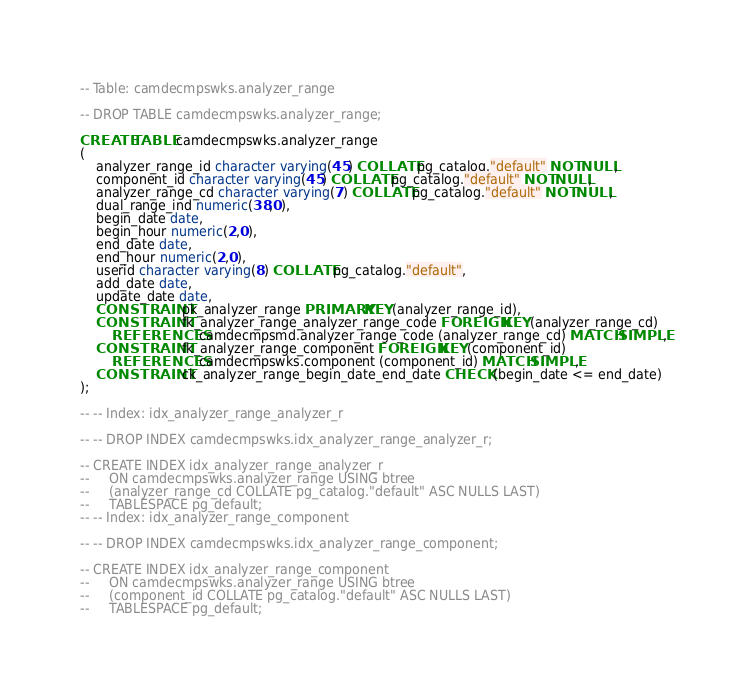Convert code to text. <code><loc_0><loc_0><loc_500><loc_500><_SQL_>-- Table: camdecmpswks.analyzer_range

-- DROP TABLE camdecmpswks.analyzer_range;

CREATE TABLE camdecmpswks.analyzer_range
(
    analyzer_range_id character varying(45) COLLATE pg_catalog."default" NOT NULL,
    component_id character varying(45) COLLATE pg_catalog."default" NOT NULL,
    analyzer_range_cd character varying(7) COLLATE pg_catalog."default" NOT NULL,
    dual_range_ind numeric(38,0),
    begin_date date,
    begin_hour numeric(2,0),
    end_date date,
    end_hour numeric(2,0),
    userid character varying(8) COLLATE pg_catalog."default",
    add_date date,
    update_date date,
    CONSTRAINT pk_analyzer_range PRIMARY KEY (analyzer_range_id),
    CONSTRAINT fk_analyzer_range_analyzer_range_code FOREIGN KEY (analyzer_range_cd)
        REFERENCES camdecmpsmd.analyzer_range_code (analyzer_range_cd) MATCH SIMPLE,
    CONSTRAINT fk_analyzer_range_component FOREIGN KEY (component_id)
        REFERENCES camdecmpswks.component (component_id) MATCH SIMPLE,
    CONSTRAINT ck_analyzer_range_begin_date_end_date CHECK (begin_date <= end_date)
);

-- -- Index: idx_analyzer_range_analyzer_r

-- -- DROP INDEX camdecmpswks.idx_analyzer_range_analyzer_r;

-- CREATE INDEX idx_analyzer_range_analyzer_r
--     ON camdecmpswks.analyzer_range USING btree
--     (analyzer_range_cd COLLATE pg_catalog."default" ASC NULLS LAST)
--     TABLESPACE pg_default;
-- -- Index: idx_analyzer_range_component

-- -- DROP INDEX camdecmpswks.idx_analyzer_range_component;

-- CREATE INDEX idx_analyzer_range_component
--     ON camdecmpswks.analyzer_range USING btree
--     (component_id COLLATE pg_catalog."default" ASC NULLS LAST)
--     TABLESPACE pg_default;</code> 